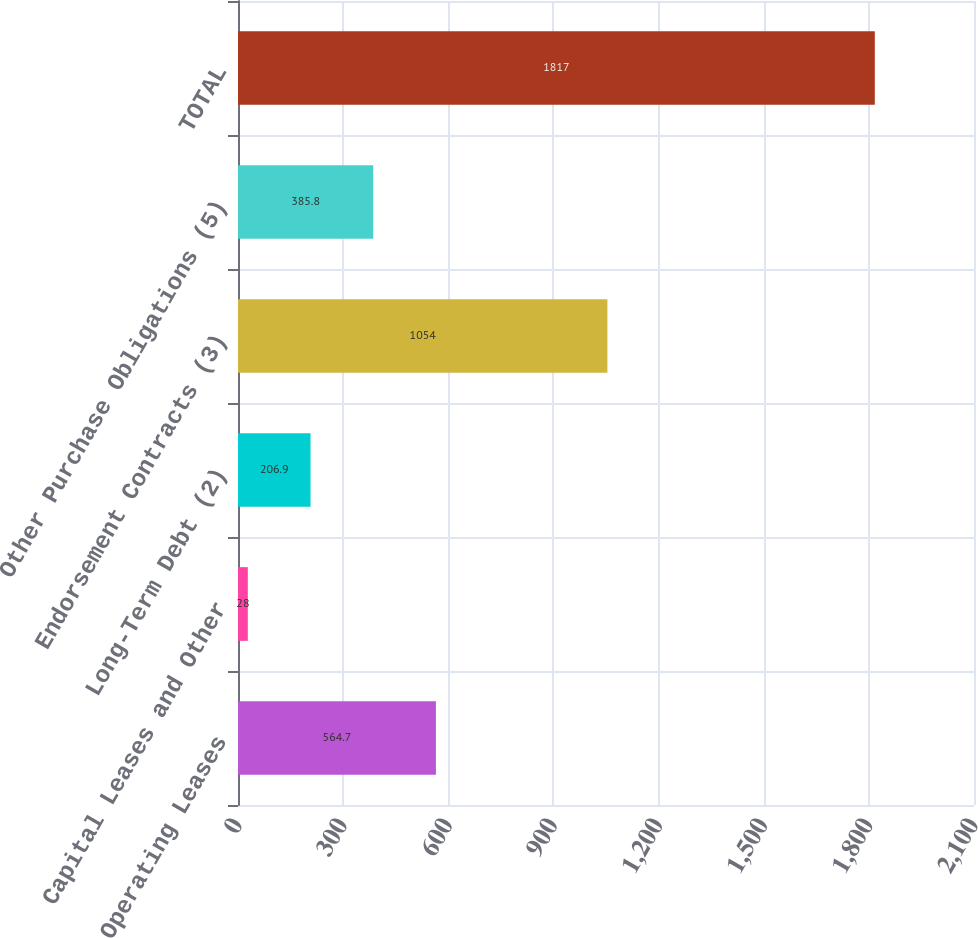Convert chart. <chart><loc_0><loc_0><loc_500><loc_500><bar_chart><fcel>Operating Leases<fcel>Capital Leases and Other<fcel>Long-Term Debt (2)<fcel>Endorsement Contracts (3)<fcel>Other Purchase Obligations (5)<fcel>TOTAL<nl><fcel>564.7<fcel>28<fcel>206.9<fcel>1054<fcel>385.8<fcel>1817<nl></chart> 